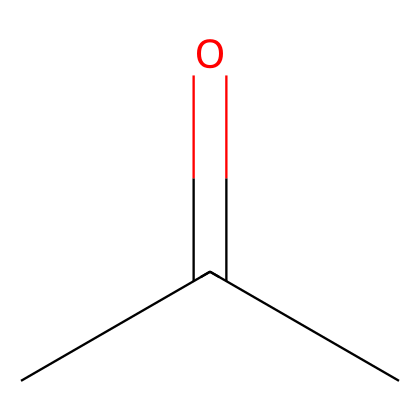What is the molecular formula of this chemical? The given SMILES represents the structure of acetone, which has three carbon atoms (C), six hydrogen atoms (H), and one oxygen atom (O). Thus, the molecular formula is C3H6O.
Answer: C3H6O How many carbon atoms are in acetone? The SMILES notation shows three 'C' characters, indicating that there are three carbon atoms in the structure of acetone.
Answer: 3 What type of functional group does acetone contain? The presence of the carbonyl group (C=O) in the structure indicates that acetone contains a ketone functional group.
Answer: ketone How many hydrogen atoms are connected to the central carbon atom in acetone? Each terminal carbon atom in acetone is bonded to three hydrogen atoms, while the central carbon is connected to one hydrogen. Therefore, it's bonded to one hydrogen atom.
Answer: 1 What is the total number of bonds in this molecule? Analyzing the structure, acetone has three carbon-carbon (C-C) bonds and one carbon-oxygen (C=O) bond, totaling four bonds. Additionally, each terminal carbon has three carbon-hydrogen (C-H) bonds, contributing to six, leading to a total of ten bonds.
Answer: 10 What makes acetone an effective solvent for cleaning cement equipment? Acetone's low boiling point and ability to dissolve a wide range of substances due to its polar nature and small size make it effective in removing residues from cement equipment.
Answer: polar nature 